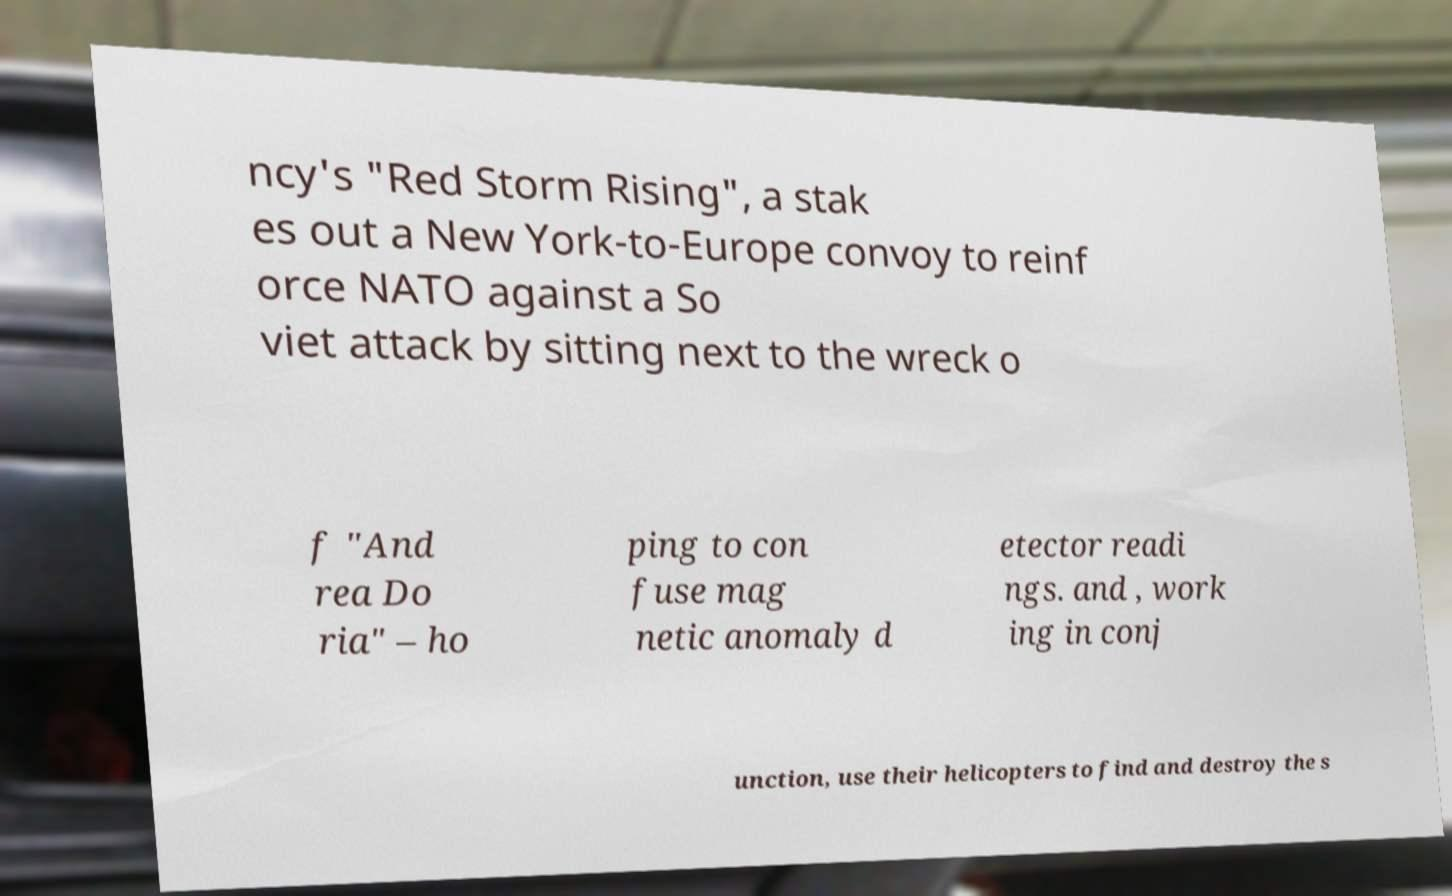What messages or text are displayed in this image? I need them in a readable, typed format. ncy's "Red Storm Rising", a stak es out a New York-to-Europe convoy to reinf orce NATO against a So viet attack by sitting next to the wreck o f "And rea Do ria" – ho ping to con fuse mag netic anomaly d etector readi ngs. and , work ing in conj unction, use their helicopters to find and destroy the s 